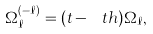Convert formula to latex. <formula><loc_0><loc_0><loc_500><loc_500>\Omega _ { \ell } ^ { ( - \ell ) } = ( t - \ t h ) \Omega _ { \ell } ,</formula> 